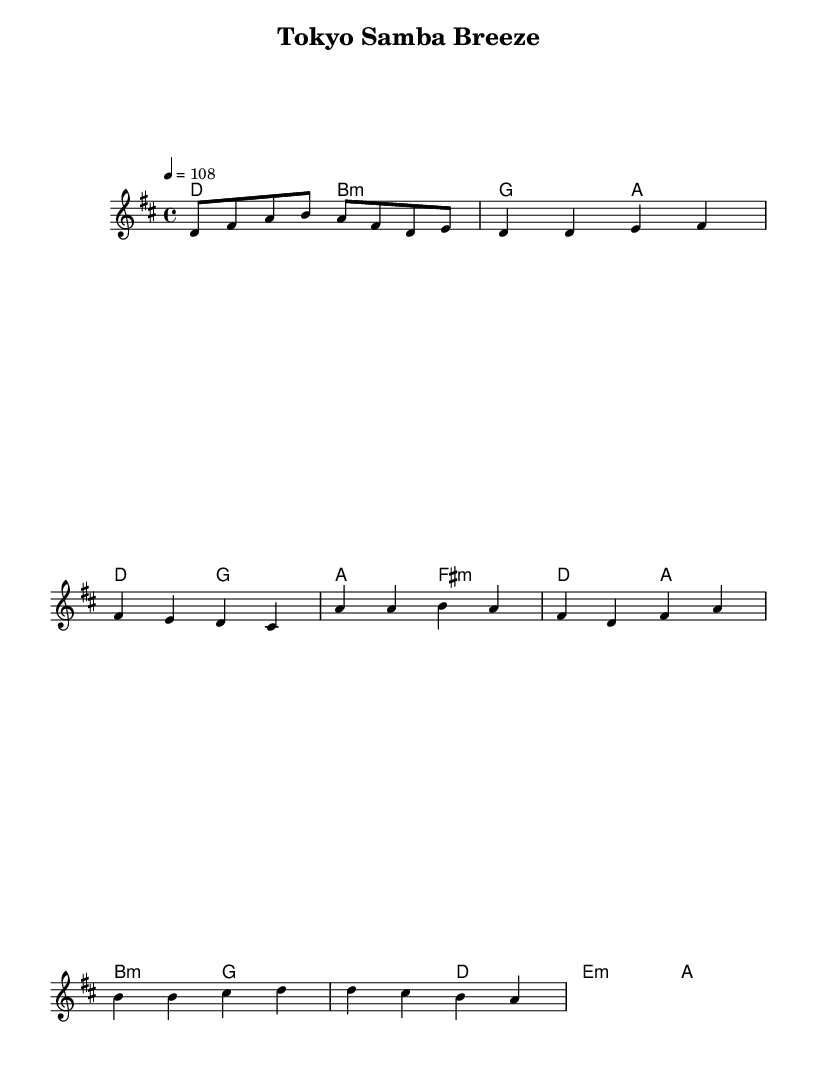What is the key signature of this music? The key signature is defined by the initial note after the word 'key' in the global section. In this case, it is D major, which has two sharps (F# and C#).
Answer: D major What is the time signature of the piece? The time signature can be found in the global section, following the word 'time.' Here, it is shown as 4/4, indicating four beats per measure.
Answer: 4/4 What is the tempo marking of the piece? The tempo marking is indicated in the global section by the word 'tempo.' Here, it notes that the beats are to be played at 108 beats per minute.
Answer: 108 In which section does the melody rise to a high note? To find this, I examined the melody section, noting the highest relative pitches. The melody reaches a high note in the chorus, specifically on the note A.
Answer: chorus What chord is played with the note F# in the verse? The verse section indicates the harmony chords, and it shows that F# is paired with a minor chord, specifically as part of F# minor harmony.
Answer: F# minor How many measures are there in the bridge section? By reviewing the structure of the bridge, I counted the measures based on the provided melody and harmonies, totaling four measures in that section.
Answer: 4 Which part has the most varied rhythmic patterns? The rhythm can be assessed by examining the different sections of the piece. The chorus section features a mix of longer and shorter notes, making it rhythmically diverse.
Answer: chorus 